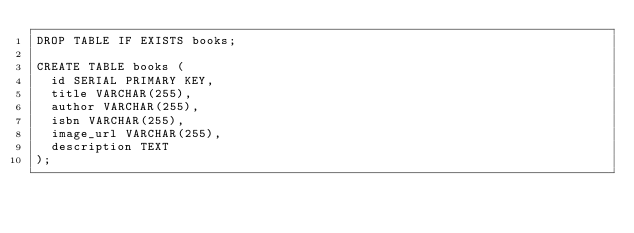<code> <loc_0><loc_0><loc_500><loc_500><_SQL_>DROP TABLE IF EXISTS books;

CREATE TABLE books (
  id SERIAL PRIMARY KEY,
  title VARCHAR(255),
  author VARCHAR(255),
  isbn VARCHAR(255),
  image_url VARCHAR(255),
  description TEXT
);</code> 